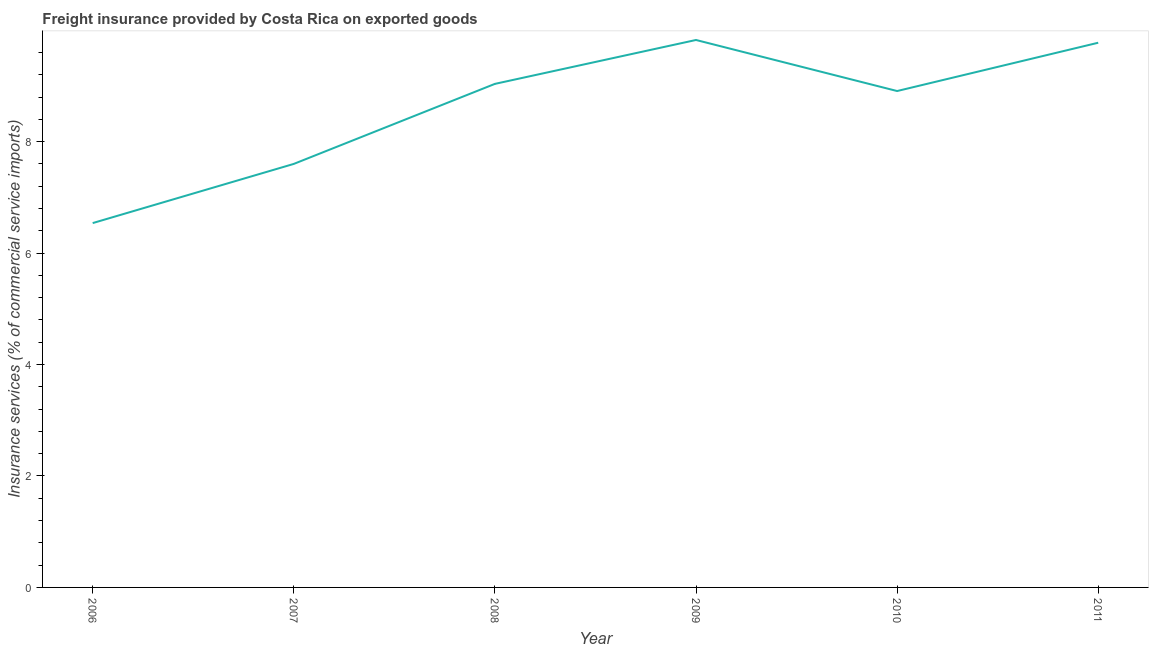What is the freight insurance in 2006?
Offer a terse response. 6.54. Across all years, what is the maximum freight insurance?
Provide a short and direct response. 9.82. Across all years, what is the minimum freight insurance?
Your answer should be compact. 6.54. In which year was the freight insurance minimum?
Your answer should be very brief. 2006. What is the sum of the freight insurance?
Your answer should be compact. 51.68. What is the difference between the freight insurance in 2007 and 2009?
Keep it short and to the point. -2.22. What is the average freight insurance per year?
Your response must be concise. 8.61. What is the median freight insurance?
Your response must be concise. 8.97. In how many years, is the freight insurance greater than 1.6 %?
Keep it short and to the point. 6. What is the ratio of the freight insurance in 2006 to that in 2011?
Provide a succinct answer. 0.67. What is the difference between the highest and the second highest freight insurance?
Ensure brevity in your answer.  0.05. What is the difference between the highest and the lowest freight insurance?
Provide a succinct answer. 3.29. Are the values on the major ticks of Y-axis written in scientific E-notation?
Ensure brevity in your answer.  No. Does the graph contain grids?
Offer a terse response. No. What is the title of the graph?
Your answer should be very brief. Freight insurance provided by Costa Rica on exported goods . What is the label or title of the X-axis?
Your response must be concise. Year. What is the label or title of the Y-axis?
Your answer should be compact. Insurance services (% of commercial service imports). What is the Insurance services (% of commercial service imports) in 2006?
Keep it short and to the point. 6.54. What is the Insurance services (% of commercial service imports) in 2007?
Keep it short and to the point. 7.6. What is the Insurance services (% of commercial service imports) of 2008?
Your response must be concise. 9.04. What is the Insurance services (% of commercial service imports) of 2009?
Give a very brief answer. 9.82. What is the Insurance services (% of commercial service imports) in 2010?
Your answer should be very brief. 8.91. What is the Insurance services (% of commercial service imports) of 2011?
Offer a terse response. 9.77. What is the difference between the Insurance services (% of commercial service imports) in 2006 and 2007?
Offer a very short reply. -1.06. What is the difference between the Insurance services (% of commercial service imports) in 2006 and 2008?
Your answer should be compact. -2.5. What is the difference between the Insurance services (% of commercial service imports) in 2006 and 2009?
Keep it short and to the point. -3.29. What is the difference between the Insurance services (% of commercial service imports) in 2006 and 2010?
Give a very brief answer. -2.37. What is the difference between the Insurance services (% of commercial service imports) in 2006 and 2011?
Your response must be concise. -3.24. What is the difference between the Insurance services (% of commercial service imports) in 2007 and 2008?
Keep it short and to the point. -1.44. What is the difference between the Insurance services (% of commercial service imports) in 2007 and 2009?
Offer a terse response. -2.22. What is the difference between the Insurance services (% of commercial service imports) in 2007 and 2010?
Provide a short and direct response. -1.31. What is the difference between the Insurance services (% of commercial service imports) in 2007 and 2011?
Make the answer very short. -2.17. What is the difference between the Insurance services (% of commercial service imports) in 2008 and 2009?
Your answer should be compact. -0.79. What is the difference between the Insurance services (% of commercial service imports) in 2008 and 2010?
Give a very brief answer. 0.13. What is the difference between the Insurance services (% of commercial service imports) in 2008 and 2011?
Keep it short and to the point. -0.74. What is the difference between the Insurance services (% of commercial service imports) in 2009 and 2010?
Offer a terse response. 0.92. What is the difference between the Insurance services (% of commercial service imports) in 2009 and 2011?
Ensure brevity in your answer.  0.05. What is the difference between the Insurance services (% of commercial service imports) in 2010 and 2011?
Your answer should be very brief. -0.87. What is the ratio of the Insurance services (% of commercial service imports) in 2006 to that in 2007?
Keep it short and to the point. 0.86. What is the ratio of the Insurance services (% of commercial service imports) in 2006 to that in 2008?
Give a very brief answer. 0.72. What is the ratio of the Insurance services (% of commercial service imports) in 2006 to that in 2009?
Keep it short and to the point. 0.67. What is the ratio of the Insurance services (% of commercial service imports) in 2006 to that in 2010?
Your answer should be very brief. 0.73. What is the ratio of the Insurance services (% of commercial service imports) in 2006 to that in 2011?
Make the answer very short. 0.67. What is the ratio of the Insurance services (% of commercial service imports) in 2007 to that in 2008?
Your response must be concise. 0.84. What is the ratio of the Insurance services (% of commercial service imports) in 2007 to that in 2009?
Provide a succinct answer. 0.77. What is the ratio of the Insurance services (% of commercial service imports) in 2007 to that in 2010?
Your response must be concise. 0.85. What is the ratio of the Insurance services (% of commercial service imports) in 2007 to that in 2011?
Keep it short and to the point. 0.78. What is the ratio of the Insurance services (% of commercial service imports) in 2008 to that in 2011?
Your response must be concise. 0.92. What is the ratio of the Insurance services (% of commercial service imports) in 2009 to that in 2010?
Keep it short and to the point. 1.1. What is the ratio of the Insurance services (% of commercial service imports) in 2010 to that in 2011?
Offer a terse response. 0.91. 